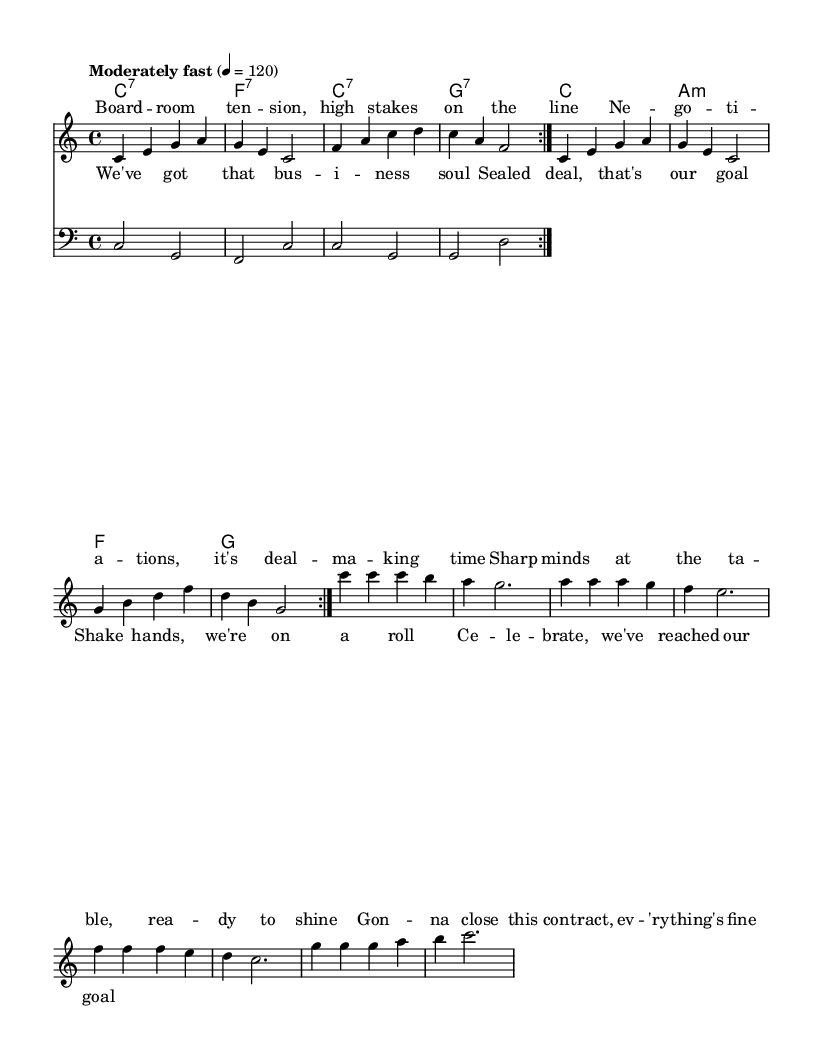What is the key signature of this music? The key signature is indicated at the beginning of the score and shows that this piece is in C major, which has no sharps or flats.
Answer: C major What is the time signature of this piece? The time signature is located at the beginning near the key signature and indicates the piece is written in 4/4 time, meaning there are four beats in each measure.
Answer: 4/4 What is the tempo marking for this music? The tempo marking is found within the global settings of the score, showing that it should be played at a tempo of 120 beats per minute, marked as "Moderately fast."
Answer: Moderately fast How many measures are in the melody section? Counting the repeat signs and the measures shown in the melody, there are a total of 16 measures, as the section contains two repeated sets of 8 measures each.
Answer: 16 What is the first chord played in the chorus? The first chord for the chorus section can be inferred from the chord progression and is C major, as indicated in the chord names.
Answer: C What do the lyrics of the chorus express in context? The chorus comprises a celebration of successful negotiations, emphasizing the joyous outcome and unity after sealing the deal, reflecting the upbeat nature of the song.
Answer: Celebration of successful negotiations What emotions are conveyed in the verse based on the lyrics? The lyrics in the verse convey a sense of anticipation, confidence, and determination as they discuss preparing for negotiations, signifying a journey towards business success.
Answer: Anticipation and confidence 